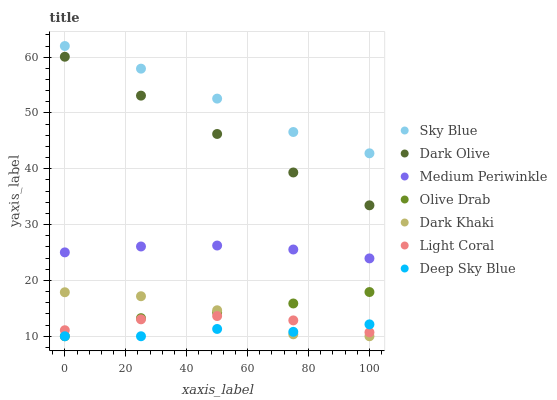Does Deep Sky Blue have the minimum area under the curve?
Answer yes or no. Yes. Does Sky Blue have the maximum area under the curve?
Answer yes or no. Yes. Does Dark Olive have the minimum area under the curve?
Answer yes or no. No. Does Dark Olive have the maximum area under the curve?
Answer yes or no. No. Is Dark Olive the smoothest?
Answer yes or no. Yes. Is Dark Khaki the roughest?
Answer yes or no. Yes. Is Medium Periwinkle the smoothest?
Answer yes or no. No. Is Medium Periwinkle the roughest?
Answer yes or no. No. Does Dark Khaki have the lowest value?
Answer yes or no. Yes. Does Dark Olive have the lowest value?
Answer yes or no. No. Does Sky Blue have the highest value?
Answer yes or no. Yes. Does Dark Olive have the highest value?
Answer yes or no. No. Is Dark Olive less than Sky Blue?
Answer yes or no. Yes. Is Sky Blue greater than Dark Olive?
Answer yes or no. Yes. Does Olive Drab intersect Dark Khaki?
Answer yes or no. Yes. Is Olive Drab less than Dark Khaki?
Answer yes or no. No. Is Olive Drab greater than Dark Khaki?
Answer yes or no. No. Does Dark Olive intersect Sky Blue?
Answer yes or no. No. 